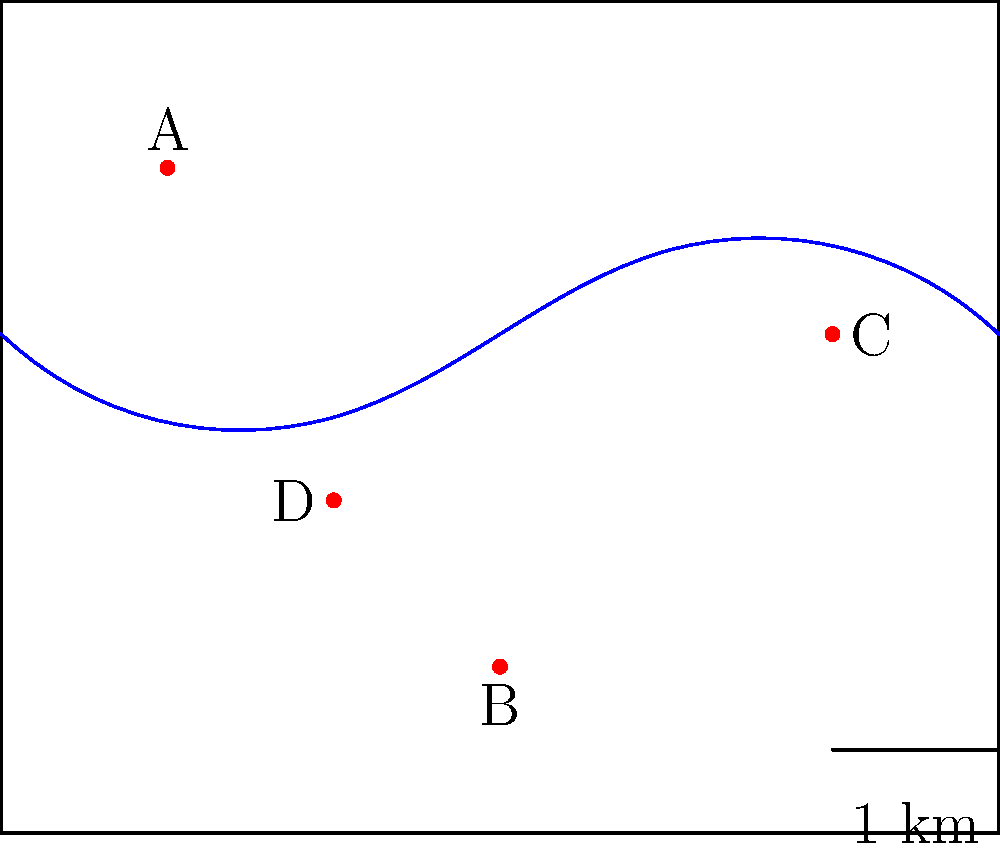Based on the aerial photograph of the tribal land, which sacred site forms the vertex of an isosceles triangle with the other three sites, and what is the approximate area of this triangle in square kilometers? To solve this problem, we need to follow these steps:

1. Identify the isosceles triangle:
   - An isosceles triangle has two equal sides.
   - By visual inspection, we can see that site C forms an isosceles triangle with sites A, B, and D.

2. Confirm the isosceles triangle:
   - The distances CA and CB appear to be equal.
   - We can verify this by using the distance formula: $d = \sqrt{(x_2-x_1)^2 + (y_2-y_1)^2}$
   - CA: $\sqrt{(5-1)^2 + (3-4)^2} = \sqrt{16 + 1} = \sqrt{17}$
   - CB: $\sqrt{(5-3)^2 + (3-1)^2} = \sqrt{4 + 4} = \sqrt{8} = 2\sqrt{2}$
   - These are approximately equal (both ≈ 4.12 units)

3. Calculate the area of the triangle:
   - We can use Heron's formula: $A = \sqrt{s(s-a)(s-b)(s-c)}$
   where $s = \frac{a+b+c}{2}$ (semi-perimeter)
   - a = CA ≈ 4.12
   - b = CB ≈ 4.12
   - c = AB ≈ 3.61 (calculated using the distance formula)
   - $s = \frac{4.12 + 4.12 + 3.61}{2} ≈ 5.925$
   - $A = \sqrt{5.925(5.925-4.12)(5.925-4.12)(5.925-3.61)} ≈ 6.93$ square units

4. Convert to square kilometers:
   - The scale shows 1 unit = 1 km
   - Therefore, the area is approximately 6.93 sq km
Answer: Site C; 6.93 sq km 